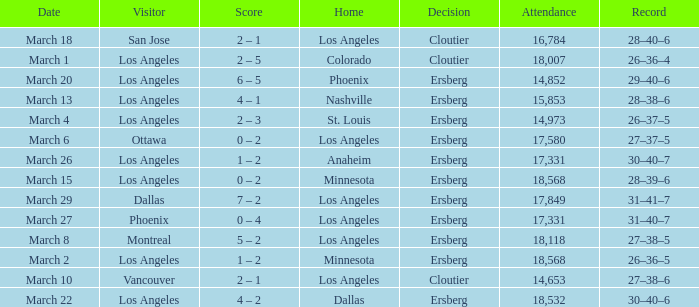What is the Decision listed when the Home was Colorado? Cloutier. 